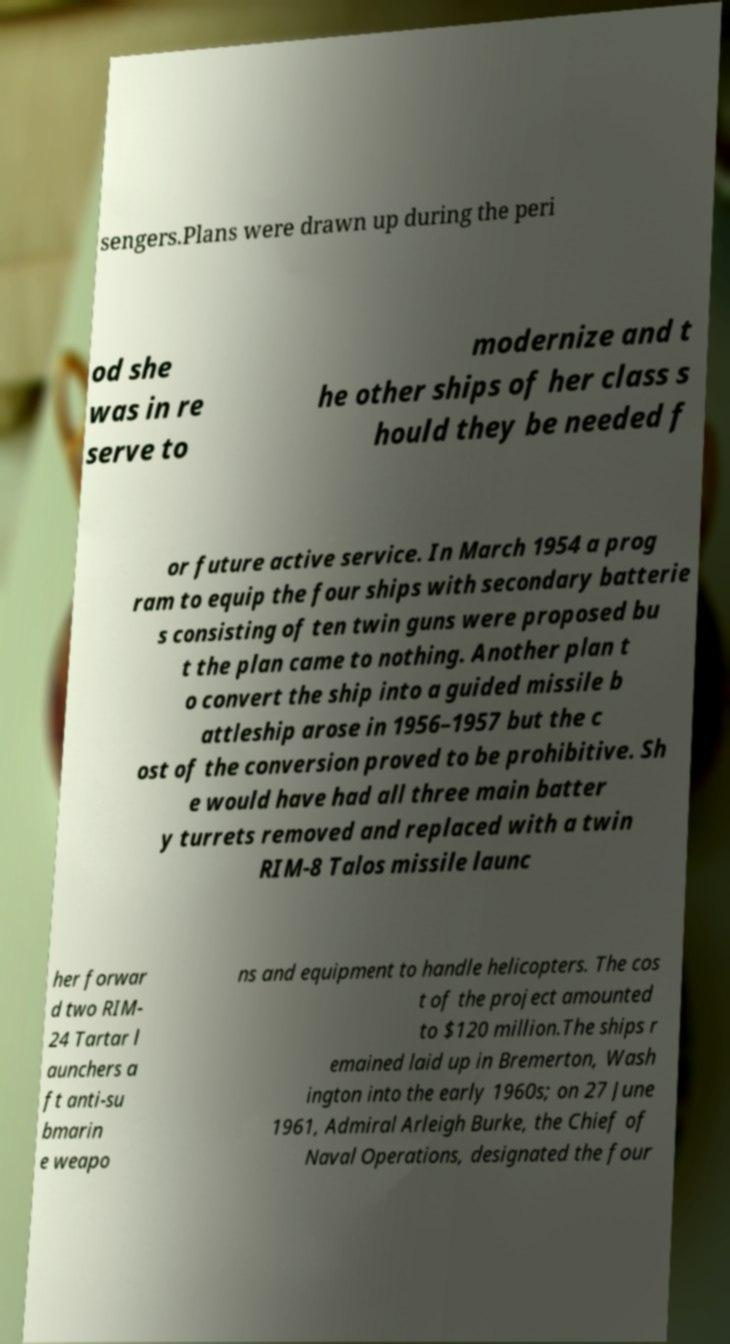Can you read and provide the text displayed in the image?This photo seems to have some interesting text. Can you extract and type it out for me? sengers.Plans were drawn up during the peri od she was in re serve to modernize and t he other ships of her class s hould they be needed f or future active service. In March 1954 a prog ram to equip the four ships with secondary batterie s consisting of ten twin guns were proposed bu t the plan came to nothing. Another plan t o convert the ship into a guided missile b attleship arose in 1956–1957 but the c ost of the conversion proved to be prohibitive. Sh e would have had all three main batter y turrets removed and replaced with a twin RIM-8 Talos missile launc her forwar d two RIM- 24 Tartar l aunchers a ft anti-su bmarin e weapo ns and equipment to handle helicopters. The cos t of the project amounted to $120 million.The ships r emained laid up in Bremerton, Wash ington into the early 1960s; on 27 June 1961, Admiral Arleigh Burke, the Chief of Naval Operations, designated the four 